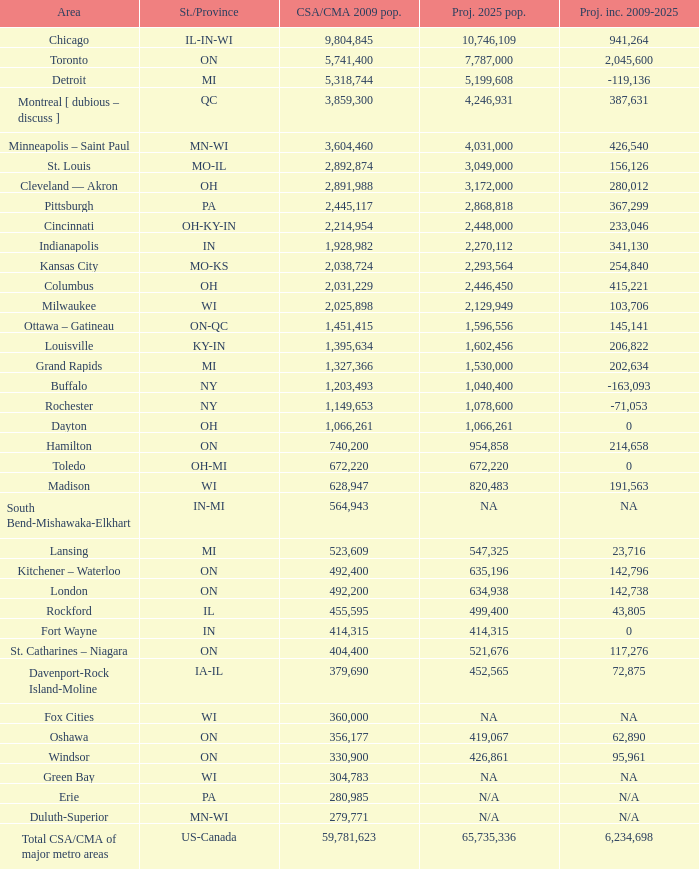What's the CSA/CMA Population in IA-IL? 379690.0. Give me the full table as a dictionary. {'header': ['Area', 'St./Province', 'CSA/CMA 2009 pop.', 'Proj. 2025 pop.', 'Proj. inc. 2009-2025'], 'rows': [['Chicago', 'IL-IN-WI', '9,804,845', '10,746,109', '941,264'], ['Toronto', 'ON', '5,741,400', '7,787,000', '2,045,600'], ['Detroit', 'MI', '5,318,744', '5,199,608', '-119,136'], ['Montreal [ dubious – discuss ]', 'QC', '3,859,300', '4,246,931', '387,631'], ['Minneapolis – Saint Paul', 'MN-WI', '3,604,460', '4,031,000', '426,540'], ['St. Louis', 'MO-IL', '2,892,874', '3,049,000', '156,126'], ['Cleveland — Akron', 'OH', '2,891,988', '3,172,000', '280,012'], ['Pittsburgh', 'PA', '2,445,117', '2,868,818', '367,299'], ['Cincinnati', 'OH-KY-IN', '2,214,954', '2,448,000', '233,046'], ['Indianapolis', 'IN', '1,928,982', '2,270,112', '341,130'], ['Kansas City', 'MO-KS', '2,038,724', '2,293,564', '254,840'], ['Columbus', 'OH', '2,031,229', '2,446,450', '415,221'], ['Milwaukee', 'WI', '2,025,898', '2,129,949', '103,706'], ['Ottawa – Gatineau', 'ON-QC', '1,451,415', '1,596,556', '145,141'], ['Louisville', 'KY-IN', '1,395,634', '1,602,456', '206,822'], ['Grand Rapids', 'MI', '1,327,366', '1,530,000', '202,634'], ['Buffalo', 'NY', '1,203,493', '1,040,400', '-163,093'], ['Rochester', 'NY', '1,149,653', '1,078,600', '-71,053'], ['Dayton', 'OH', '1,066,261', '1,066,261', '0'], ['Hamilton', 'ON', '740,200', '954,858', '214,658'], ['Toledo', 'OH-MI', '672,220', '672,220', '0'], ['Madison', 'WI', '628,947', '820,483', '191,563'], ['South Bend-Mishawaka-Elkhart', 'IN-MI', '564,943', 'NA', 'NA'], ['Lansing', 'MI', '523,609', '547,325', '23,716'], ['Kitchener – Waterloo', 'ON', '492,400', '635,196', '142,796'], ['London', 'ON', '492,200', '634,938', '142,738'], ['Rockford', 'IL', '455,595', '499,400', '43,805'], ['Fort Wayne', 'IN', '414,315', '414,315', '0'], ['St. Catharines – Niagara', 'ON', '404,400', '521,676', '117,276'], ['Davenport-Rock Island-Moline', 'IA-IL', '379,690', '452,565', '72,875'], ['Fox Cities', 'WI', '360,000', 'NA', 'NA'], ['Oshawa', 'ON', '356,177', '419,067', '62,890'], ['Windsor', 'ON', '330,900', '426,861', '95,961'], ['Green Bay', 'WI', '304,783', 'NA', 'NA'], ['Erie', 'PA', '280,985', 'N/A', 'N/A'], ['Duluth-Superior', 'MN-WI', '279,771', 'N/A', 'N/A'], ['Total CSA/CMA of major metro areas', 'US-Canada', '59,781,623', '65,735,336', '6,234,698']]} 